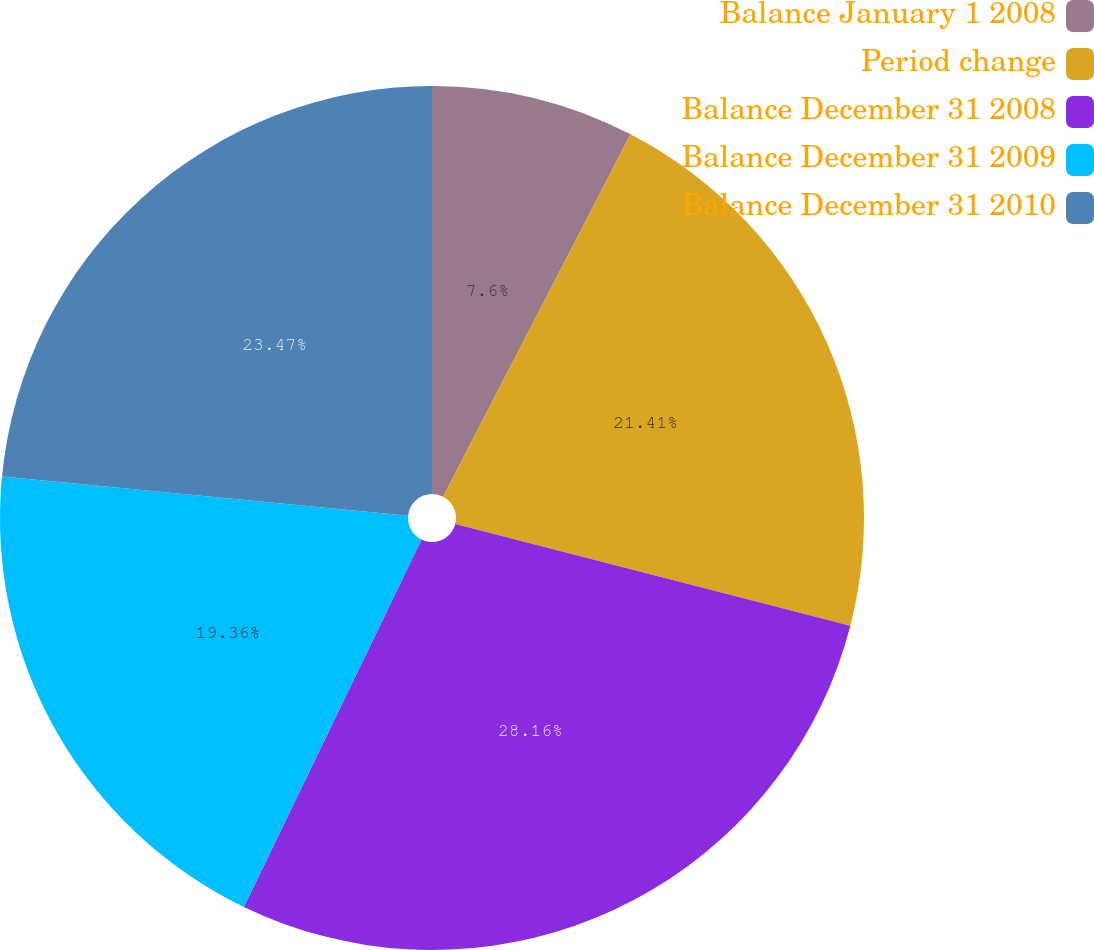Convert chart. <chart><loc_0><loc_0><loc_500><loc_500><pie_chart><fcel>Balance January 1 2008<fcel>Period change<fcel>Balance December 31 2008<fcel>Balance December 31 2009<fcel>Balance December 31 2010<nl><fcel>7.6%<fcel>21.41%<fcel>28.16%<fcel>19.36%<fcel>23.47%<nl></chart> 